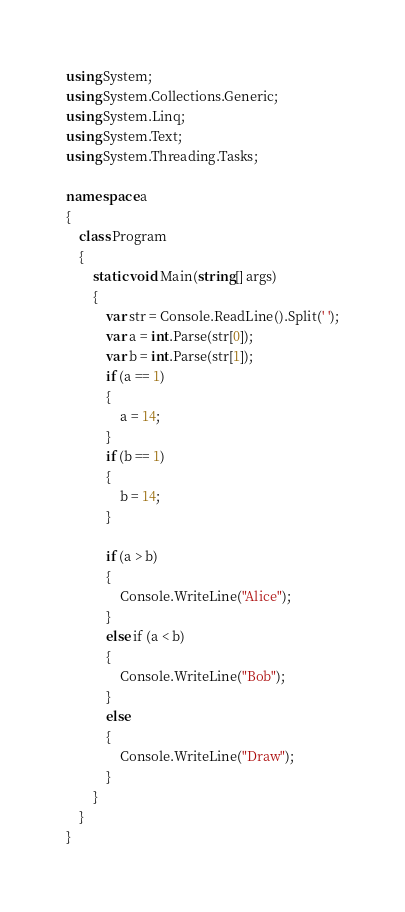<code> <loc_0><loc_0><loc_500><loc_500><_C#_>using System;
using System.Collections.Generic;
using System.Linq;
using System.Text;
using System.Threading.Tasks;

namespace a
{
    class Program
    {
        static void Main(string[] args)
        {
            var str = Console.ReadLine().Split(' ');
            var a = int.Parse(str[0]);
            var b = int.Parse(str[1]);
            if (a == 1)
            {
                a = 14;
            }
            if (b == 1)
            {
                b = 14;
            }

            if (a > b)
            {
                Console.WriteLine("Alice");
            }
            else if (a < b)
            {
                Console.WriteLine("Bob");
            }
            else
            {
                Console.WriteLine("Draw");
            }
        }
    }
}
</code> 